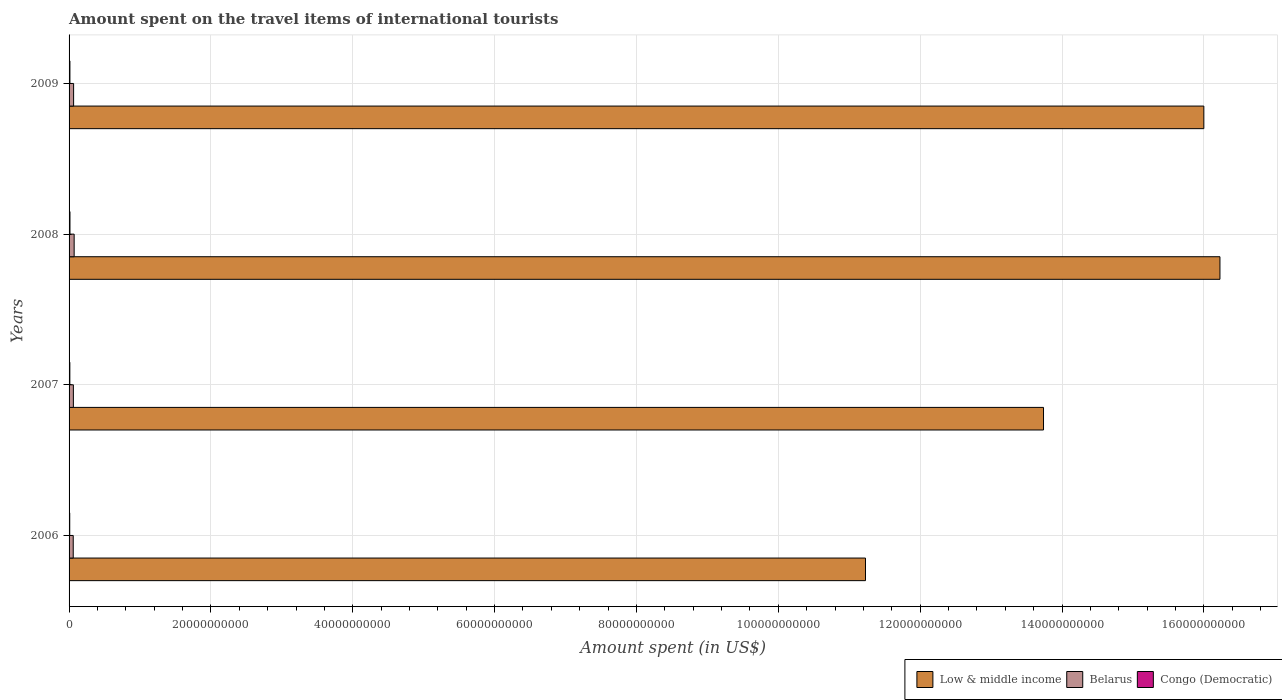How many different coloured bars are there?
Make the answer very short. 3. Are the number of bars per tick equal to the number of legend labels?
Give a very brief answer. Yes. Are the number of bars on each tick of the Y-axis equal?
Provide a succinct answer. Yes. How many bars are there on the 4th tick from the top?
Offer a very short reply. 3. How many bars are there on the 4th tick from the bottom?
Your answer should be very brief. 3. What is the amount spent on the travel items of international tourists in Congo (Democratic) in 2009?
Offer a very short reply. 1.21e+08. Across all years, what is the maximum amount spent on the travel items of international tourists in Belarus?
Provide a short and direct response. 7.16e+08. Across all years, what is the minimum amount spent on the travel items of international tourists in Congo (Democratic)?
Provide a succinct answer. 9.30e+07. In which year was the amount spent on the travel items of international tourists in Congo (Democratic) minimum?
Your response must be concise. 2006. What is the total amount spent on the travel items of international tourists in Low & middle income in the graph?
Give a very brief answer. 5.72e+11. What is the difference between the amount spent on the travel items of international tourists in Low & middle income in 2008 and that in 2009?
Your answer should be compact. 2.27e+09. What is the difference between the amount spent on the travel items of international tourists in Belarus in 2006 and the amount spent on the travel items of international tourists in Low & middle income in 2008?
Make the answer very short. -1.62e+11. What is the average amount spent on the travel items of international tourists in Low & middle income per year?
Give a very brief answer. 1.43e+11. In the year 2007, what is the difference between the amount spent on the travel items of international tourists in Congo (Democratic) and amount spent on the travel items of international tourists in Low & middle income?
Offer a very short reply. -1.37e+11. What is the ratio of the amount spent on the travel items of international tourists in Low & middle income in 2006 to that in 2009?
Keep it short and to the point. 0.7. What is the difference between the highest and the second highest amount spent on the travel items of international tourists in Belarus?
Ensure brevity in your answer.  7.70e+07. What is the difference between the highest and the lowest amount spent on the travel items of international tourists in Belarus?
Give a very brief answer. 1.30e+08. Is the sum of the amount spent on the travel items of international tourists in Belarus in 2007 and 2008 greater than the maximum amount spent on the travel items of international tourists in Low & middle income across all years?
Provide a short and direct response. No. What does the 2nd bar from the bottom in 2007 represents?
Your answer should be very brief. Belarus. Are all the bars in the graph horizontal?
Your answer should be very brief. Yes. Does the graph contain any zero values?
Offer a very short reply. No. Does the graph contain grids?
Keep it short and to the point. Yes. How many legend labels are there?
Give a very brief answer. 3. How are the legend labels stacked?
Give a very brief answer. Horizontal. What is the title of the graph?
Offer a very short reply. Amount spent on the travel items of international tourists. Does "Lower middle income" appear as one of the legend labels in the graph?
Your answer should be compact. No. What is the label or title of the X-axis?
Your response must be concise. Amount spent (in US$). What is the Amount spent (in US$) of Low & middle income in 2006?
Make the answer very short. 1.12e+11. What is the Amount spent (in US$) of Belarus in 2006?
Ensure brevity in your answer.  5.86e+08. What is the Amount spent (in US$) of Congo (Democratic) in 2006?
Provide a short and direct response. 9.30e+07. What is the Amount spent (in US$) in Low & middle income in 2007?
Keep it short and to the point. 1.37e+11. What is the Amount spent (in US$) in Belarus in 2007?
Ensure brevity in your answer.  6.06e+08. What is the Amount spent (in US$) in Congo (Democratic) in 2007?
Keep it short and to the point. 1.09e+08. What is the Amount spent (in US$) in Low & middle income in 2008?
Offer a very short reply. 1.62e+11. What is the Amount spent (in US$) in Belarus in 2008?
Your response must be concise. 7.16e+08. What is the Amount spent (in US$) of Congo (Democratic) in 2008?
Give a very brief answer. 1.27e+08. What is the Amount spent (in US$) of Low & middle income in 2009?
Ensure brevity in your answer.  1.60e+11. What is the Amount spent (in US$) of Belarus in 2009?
Ensure brevity in your answer.  6.39e+08. What is the Amount spent (in US$) in Congo (Democratic) in 2009?
Make the answer very short. 1.21e+08. Across all years, what is the maximum Amount spent (in US$) of Low & middle income?
Your response must be concise. 1.62e+11. Across all years, what is the maximum Amount spent (in US$) in Belarus?
Keep it short and to the point. 7.16e+08. Across all years, what is the maximum Amount spent (in US$) of Congo (Democratic)?
Give a very brief answer. 1.27e+08. Across all years, what is the minimum Amount spent (in US$) of Low & middle income?
Offer a very short reply. 1.12e+11. Across all years, what is the minimum Amount spent (in US$) in Belarus?
Keep it short and to the point. 5.86e+08. Across all years, what is the minimum Amount spent (in US$) in Congo (Democratic)?
Your answer should be very brief. 9.30e+07. What is the total Amount spent (in US$) of Low & middle income in the graph?
Offer a terse response. 5.72e+11. What is the total Amount spent (in US$) in Belarus in the graph?
Your answer should be very brief. 2.55e+09. What is the total Amount spent (in US$) of Congo (Democratic) in the graph?
Keep it short and to the point. 4.50e+08. What is the difference between the Amount spent (in US$) of Low & middle income in 2006 and that in 2007?
Your answer should be compact. -2.51e+1. What is the difference between the Amount spent (in US$) in Belarus in 2006 and that in 2007?
Ensure brevity in your answer.  -2.00e+07. What is the difference between the Amount spent (in US$) of Congo (Democratic) in 2006 and that in 2007?
Offer a terse response. -1.60e+07. What is the difference between the Amount spent (in US$) in Low & middle income in 2006 and that in 2008?
Make the answer very short. -5.00e+1. What is the difference between the Amount spent (in US$) of Belarus in 2006 and that in 2008?
Give a very brief answer. -1.30e+08. What is the difference between the Amount spent (in US$) in Congo (Democratic) in 2006 and that in 2008?
Your answer should be compact. -3.40e+07. What is the difference between the Amount spent (in US$) in Low & middle income in 2006 and that in 2009?
Your response must be concise. -4.77e+1. What is the difference between the Amount spent (in US$) in Belarus in 2006 and that in 2009?
Give a very brief answer. -5.30e+07. What is the difference between the Amount spent (in US$) of Congo (Democratic) in 2006 and that in 2009?
Keep it short and to the point. -2.80e+07. What is the difference between the Amount spent (in US$) of Low & middle income in 2007 and that in 2008?
Offer a very short reply. -2.49e+1. What is the difference between the Amount spent (in US$) of Belarus in 2007 and that in 2008?
Ensure brevity in your answer.  -1.10e+08. What is the difference between the Amount spent (in US$) of Congo (Democratic) in 2007 and that in 2008?
Your answer should be very brief. -1.80e+07. What is the difference between the Amount spent (in US$) of Low & middle income in 2007 and that in 2009?
Your answer should be very brief. -2.26e+1. What is the difference between the Amount spent (in US$) of Belarus in 2007 and that in 2009?
Keep it short and to the point. -3.30e+07. What is the difference between the Amount spent (in US$) in Congo (Democratic) in 2007 and that in 2009?
Your answer should be very brief. -1.20e+07. What is the difference between the Amount spent (in US$) of Low & middle income in 2008 and that in 2009?
Provide a short and direct response. 2.27e+09. What is the difference between the Amount spent (in US$) of Belarus in 2008 and that in 2009?
Give a very brief answer. 7.70e+07. What is the difference between the Amount spent (in US$) of Congo (Democratic) in 2008 and that in 2009?
Your answer should be compact. 6.00e+06. What is the difference between the Amount spent (in US$) of Low & middle income in 2006 and the Amount spent (in US$) of Belarus in 2007?
Make the answer very short. 1.12e+11. What is the difference between the Amount spent (in US$) in Low & middle income in 2006 and the Amount spent (in US$) in Congo (Democratic) in 2007?
Provide a succinct answer. 1.12e+11. What is the difference between the Amount spent (in US$) in Belarus in 2006 and the Amount spent (in US$) in Congo (Democratic) in 2007?
Your answer should be very brief. 4.77e+08. What is the difference between the Amount spent (in US$) in Low & middle income in 2006 and the Amount spent (in US$) in Belarus in 2008?
Keep it short and to the point. 1.12e+11. What is the difference between the Amount spent (in US$) of Low & middle income in 2006 and the Amount spent (in US$) of Congo (Democratic) in 2008?
Keep it short and to the point. 1.12e+11. What is the difference between the Amount spent (in US$) in Belarus in 2006 and the Amount spent (in US$) in Congo (Democratic) in 2008?
Provide a succinct answer. 4.59e+08. What is the difference between the Amount spent (in US$) in Low & middle income in 2006 and the Amount spent (in US$) in Belarus in 2009?
Keep it short and to the point. 1.12e+11. What is the difference between the Amount spent (in US$) of Low & middle income in 2006 and the Amount spent (in US$) of Congo (Democratic) in 2009?
Give a very brief answer. 1.12e+11. What is the difference between the Amount spent (in US$) in Belarus in 2006 and the Amount spent (in US$) in Congo (Democratic) in 2009?
Offer a terse response. 4.65e+08. What is the difference between the Amount spent (in US$) in Low & middle income in 2007 and the Amount spent (in US$) in Belarus in 2008?
Give a very brief answer. 1.37e+11. What is the difference between the Amount spent (in US$) in Low & middle income in 2007 and the Amount spent (in US$) in Congo (Democratic) in 2008?
Your response must be concise. 1.37e+11. What is the difference between the Amount spent (in US$) in Belarus in 2007 and the Amount spent (in US$) in Congo (Democratic) in 2008?
Provide a short and direct response. 4.79e+08. What is the difference between the Amount spent (in US$) in Low & middle income in 2007 and the Amount spent (in US$) in Belarus in 2009?
Provide a succinct answer. 1.37e+11. What is the difference between the Amount spent (in US$) in Low & middle income in 2007 and the Amount spent (in US$) in Congo (Democratic) in 2009?
Make the answer very short. 1.37e+11. What is the difference between the Amount spent (in US$) in Belarus in 2007 and the Amount spent (in US$) in Congo (Democratic) in 2009?
Your answer should be compact. 4.85e+08. What is the difference between the Amount spent (in US$) in Low & middle income in 2008 and the Amount spent (in US$) in Belarus in 2009?
Make the answer very short. 1.62e+11. What is the difference between the Amount spent (in US$) in Low & middle income in 2008 and the Amount spent (in US$) in Congo (Democratic) in 2009?
Keep it short and to the point. 1.62e+11. What is the difference between the Amount spent (in US$) of Belarus in 2008 and the Amount spent (in US$) of Congo (Democratic) in 2009?
Your answer should be very brief. 5.95e+08. What is the average Amount spent (in US$) of Low & middle income per year?
Your answer should be compact. 1.43e+11. What is the average Amount spent (in US$) of Belarus per year?
Your response must be concise. 6.37e+08. What is the average Amount spent (in US$) in Congo (Democratic) per year?
Your answer should be compact. 1.12e+08. In the year 2006, what is the difference between the Amount spent (in US$) of Low & middle income and Amount spent (in US$) of Belarus?
Ensure brevity in your answer.  1.12e+11. In the year 2006, what is the difference between the Amount spent (in US$) in Low & middle income and Amount spent (in US$) in Congo (Democratic)?
Offer a very short reply. 1.12e+11. In the year 2006, what is the difference between the Amount spent (in US$) of Belarus and Amount spent (in US$) of Congo (Democratic)?
Your response must be concise. 4.93e+08. In the year 2007, what is the difference between the Amount spent (in US$) in Low & middle income and Amount spent (in US$) in Belarus?
Your answer should be very brief. 1.37e+11. In the year 2007, what is the difference between the Amount spent (in US$) of Low & middle income and Amount spent (in US$) of Congo (Democratic)?
Provide a succinct answer. 1.37e+11. In the year 2007, what is the difference between the Amount spent (in US$) of Belarus and Amount spent (in US$) of Congo (Democratic)?
Offer a very short reply. 4.97e+08. In the year 2008, what is the difference between the Amount spent (in US$) in Low & middle income and Amount spent (in US$) in Belarus?
Give a very brief answer. 1.62e+11. In the year 2008, what is the difference between the Amount spent (in US$) in Low & middle income and Amount spent (in US$) in Congo (Democratic)?
Keep it short and to the point. 1.62e+11. In the year 2008, what is the difference between the Amount spent (in US$) in Belarus and Amount spent (in US$) in Congo (Democratic)?
Offer a terse response. 5.89e+08. In the year 2009, what is the difference between the Amount spent (in US$) in Low & middle income and Amount spent (in US$) in Belarus?
Your response must be concise. 1.59e+11. In the year 2009, what is the difference between the Amount spent (in US$) in Low & middle income and Amount spent (in US$) in Congo (Democratic)?
Ensure brevity in your answer.  1.60e+11. In the year 2009, what is the difference between the Amount spent (in US$) of Belarus and Amount spent (in US$) of Congo (Democratic)?
Your response must be concise. 5.18e+08. What is the ratio of the Amount spent (in US$) in Low & middle income in 2006 to that in 2007?
Offer a very short reply. 0.82. What is the ratio of the Amount spent (in US$) of Belarus in 2006 to that in 2007?
Offer a terse response. 0.97. What is the ratio of the Amount spent (in US$) in Congo (Democratic) in 2006 to that in 2007?
Make the answer very short. 0.85. What is the ratio of the Amount spent (in US$) in Low & middle income in 2006 to that in 2008?
Ensure brevity in your answer.  0.69. What is the ratio of the Amount spent (in US$) in Belarus in 2006 to that in 2008?
Your answer should be compact. 0.82. What is the ratio of the Amount spent (in US$) in Congo (Democratic) in 2006 to that in 2008?
Keep it short and to the point. 0.73. What is the ratio of the Amount spent (in US$) in Low & middle income in 2006 to that in 2009?
Give a very brief answer. 0.7. What is the ratio of the Amount spent (in US$) in Belarus in 2006 to that in 2009?
Ensure brevity in your answer.  0.92. What is the ratio of the Amount spent (in US$) in Congo (Democratic) in 2006 to that in 2009?
Provide a succinct answer. 0.77. What is the ratio of the Amount spent (in US$) in Low & middle income in 2007 to that in 2008?
Offer a very short reply. 0.85. What is the ratio of the Amount spent (in US$) in Belarus in 2007 to that in 2008?
Keep it short and to the point. 0.85. What is the ratio of the Amount spent (in US$) in Congo (Democratic) in 2007 to that in 2008?
Offer a very short reply. 0.86. What is the ratio of the Amount spent (in US$) of Low & middle income in 2007 to that in 2009?
Provide a succinct answer. 0.86. What is the ratio of the Amount spent (in US$) of Belarus in 2007 to that in 2009?
Your response must be concise. 0.95. What is the ratio of the Amount spent (in US$) of Congo (Democratic) in 2007 to that in 2009?
Ensure brevity in your answer.  0.9. What is the ratio of the Amount spent (in US$) of Low & middle income in 2008 to that in 2009?
Your answer should be compact. 1.01. What is the ratio of the Amount spent (in US$) in Belarus in 2008 to that in 2009?
Give a very brief answer. 1.12. What is the ratio of the Amount spent (in US$) of Congo (Democratic) in 2008 to that in 2009?
Offer a terse response. 1.05. What is the difference between the highest and the second highest Amount spent (in US$) of Low & middle income?
Keep it short and to the point. 2.27e+09. What is the difference between the highest and the second highest Amount spent (in US$) of Belarus?
Offer a very short reply. 7.70e+07. What is the difference between the highest and the lowest Amount spent (in US$) of Low & middle income?
Give a very brief answer. 5.00e+1. What is the difference between the highest and the lowest Amount spent (in US$) of Belarus?
Keep it short and to the point. 1.30e+08. What is the difference between the highest and the lowest Amount spent (in US$) in Congo (Democratic)?
Your response must be concise. 3.40e+07. 